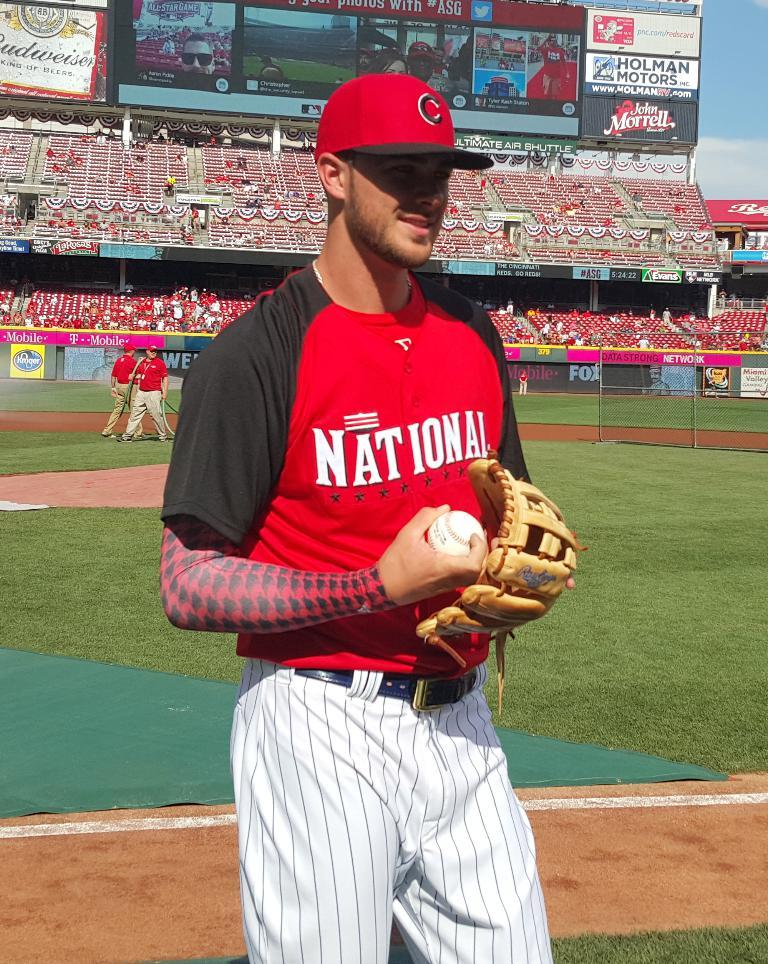Provide a one-sentence caption for the provided image. the name National that is on a jersey. 